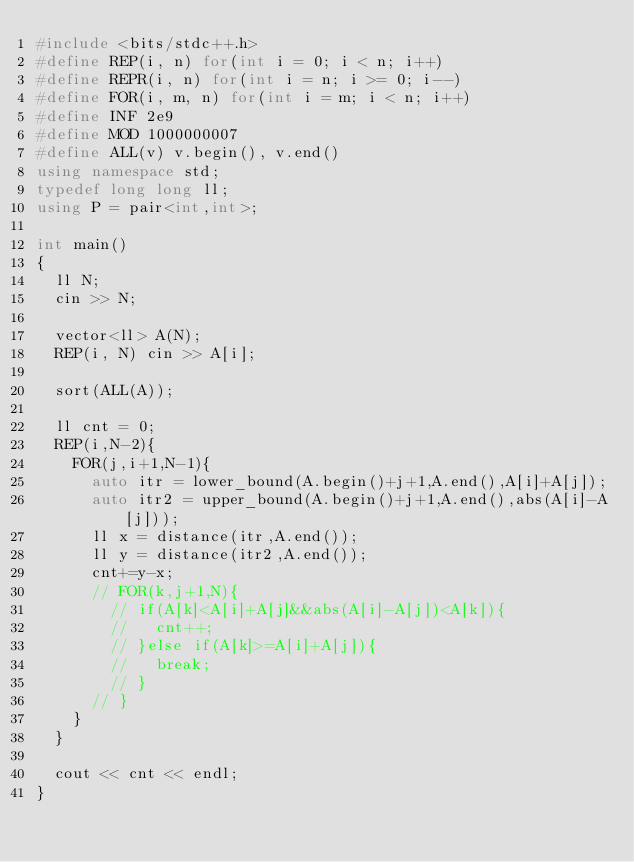Convert code to text. <code><loc_0><loc_0><loc_500><loc_500><_C++_>#include <bits/stdc++.h>
#define REP(i, n) for(int i = 0; i < n; i++)
#define REPR(i, n) for(int i = n; i >= 0; i--)
#define FOR(i, m, n) for(int i = m; i < n; i++)
#define INF 2e9
#define MOD 1000000007
#define ALL(v) v.begin(), v.end()
using namespace std;
typedef long long ll;
using P = pair<int,int>;

int main()
{
  ll N;
  cin >> N;

  vector<ll> A(N);
  REP(i, N) cin >> A[i];
  
  sort(ALL(A));

  ll cnt = 0;
  REP(i,N-2){
    FOR(j,i+1,N-1){
      auto itr = lower_bound(A.begin()+j+1,A.end(),A[i]+A[j]);
      auto itr2 = upper_bound(A.begin()+j+1,A.end(),abs(A[i]-A[j]));
      ll x = distance(itr,A.end());
      ll y = distance(itr2,A.end());
      cnt+=y-x;
      // FOR(k,j+1,N){
        // if(A[k]<A[i]+A[j]&&abs(A[i]-A[j])<A[k]){
        //   cnt++;
        // }else if(A[k]>=A[i]+A[j]){
        //   break;
        // }
      // }
    }
  }

  cout << cnt << endl;
}</code> 